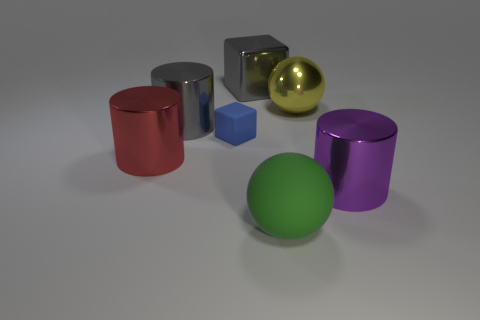Add 2 red objects. How many objects exist? 9 Subtract all big gray cylinders. How many cylinders are left? 2 Subtract 1 spheres. How many spheres are left? 1 Subtract all gray cylinders. How many cylinders are left? 2 Subtract all cubes. How many objects are left? 5 Subtract all gray cubes. Subtract all yellow balls. How many cubes are left? 1 Subtract all red cubes. How many purple cylinders are left? 1 Subtract all cyan metallic objects. Subtract all large green rubber balls. How many objects are left? 6 Add 4 shiny spheres. How many shiny spheres are left? 5 Add 2 purple objects. How many purple objects exist? 3 